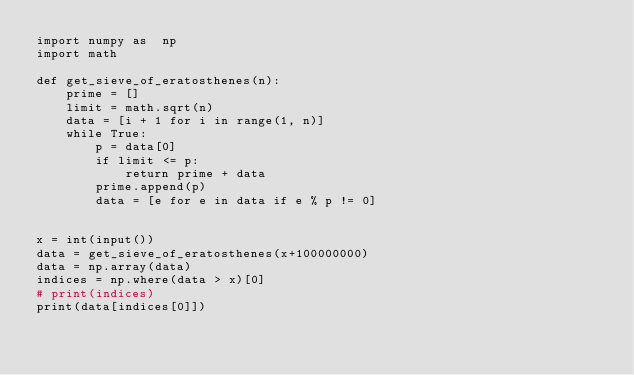<code> <loc_0><loc_0><loc_500><loc_500><_Python_>import numpy as  np
import math
 
def get_sieve_of_eratosthenes(n):
    prime = []
    limit = math.sqrt(n)
    data = [i + 1 for i in range(1, n)]
    while True:
        p = data[0]
        if limit <= p:
            return prime + data
        prime.append(p)
        data = [e for e in data if e % p != 0]
 
 
x = int(input())
data = get_sieve_of_eratosthenes(x+100000000)
data = np.array(data)
indices = np.where(data > x)[0]
# print(indices)
print(data[indices[0]])
 </code> 